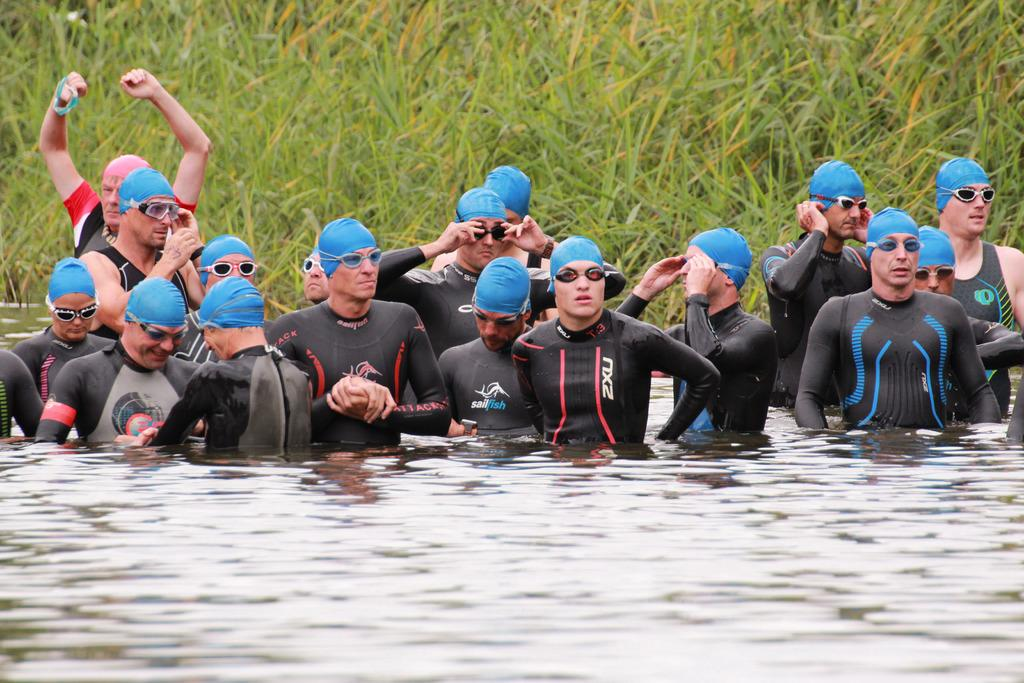What are the people in the image doing? There is a group of people in the water. What can be seen in the background of the image? There is grass visible in the background of the image. What type of soup is being cooked on the stove in the image? There is no stove or soup present in the image; it features a group of people in the water and grass in the background. 